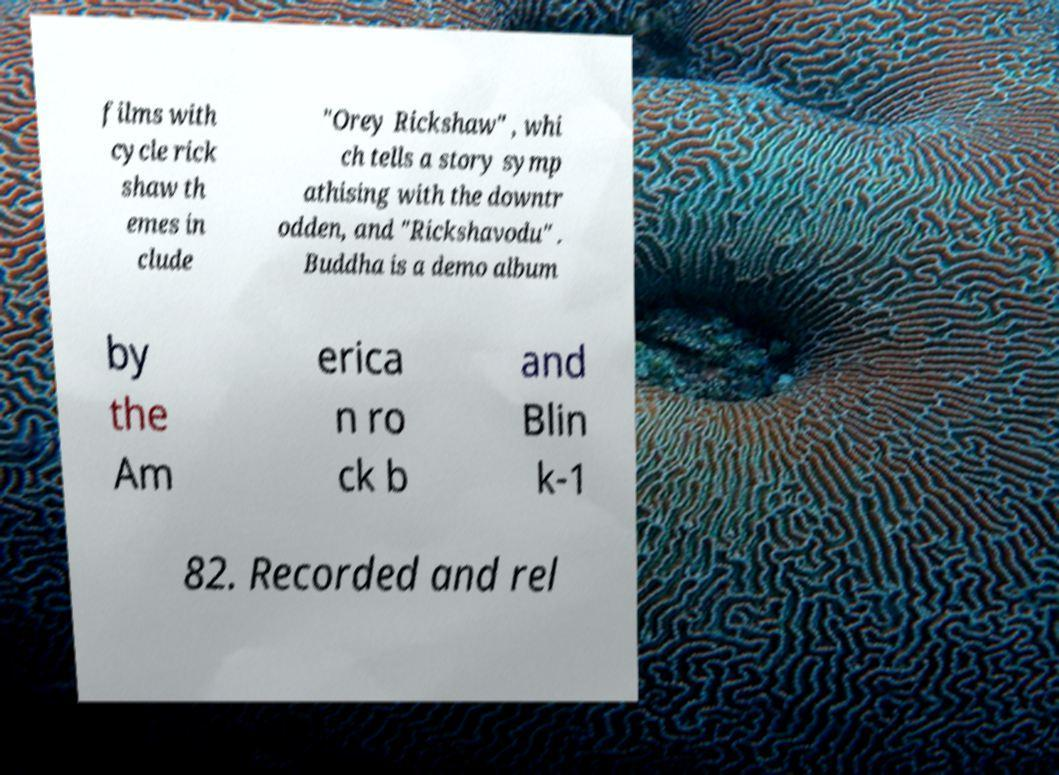I need the written content from this picture converted into text. Can you do that? films with cycle rick shaw th emes in clude "Orey Rickshaw" , whi ch tells a story symp athising with the downtr odden, and "Rickshavodu" . Buddha is a demo album by the Am erica n ro ck b and Blin k-1 82. Recorded and rel 